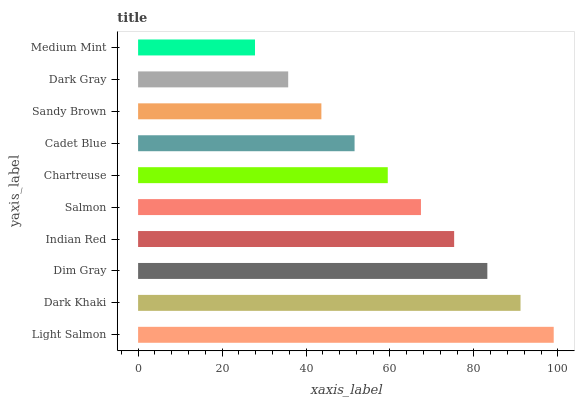Is Medium Mint the minimum?
Answer yes or no. Yes. Is Light Salmon the maximum?
Answer yes or no. Yes. Is Dark Khaki the minimum?
Answer yes or no. No. Is Dark Khaki the maximum?
Answer yes or no. No. Is Light Salmon greater than Dark Khaki?
Answer yes or no. Yes. Is Dark Khaki less than Light Salmon?
Answer yes or no. Yes. Is Dark Khaki greater than Light Salmon?
Answer yes or no. No. Is Light Salmon less than Dark Khaki?
Answer yes or no. No. Is Salmon the high median?
Answer yes or no. Yes. Is Chartreuse the low median?
Answer yes or no. Yes. Is Medium Mint the high median?
Answer yes or no. No. Is Sandy Brown the low median?
Answer yes or no. No. 